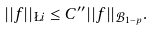<formula> <loc_0><loc_0><loc_500><loc_500>| | f | | _ { \L i } \leq C ^ { \prime \prime } | | f | | _ { { \mathcal { B } } _ { 1 - p } } .</formula> 